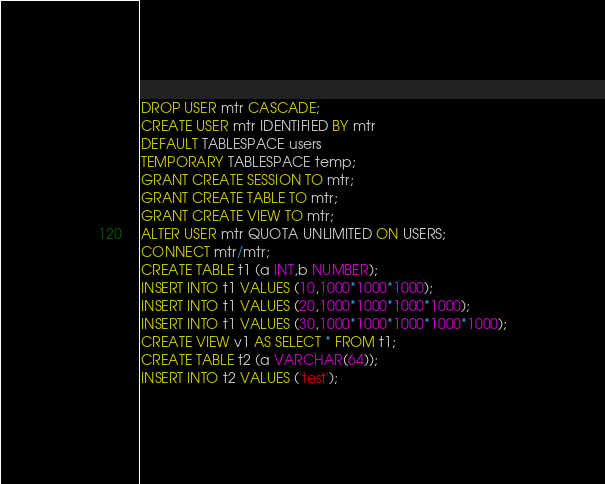<code> <loc_0><loc_0><loc_500><loc_500><_SQL_>DROP USER mtr CASCADE;
CREATE USER mtr IDENTIFIED BY mtr
DEFAULT TABLESPACE users
TEMPORARY TABLESPACE temp;
GRANT CREATE SESSION TO mtr;
GRANT CREATE TABLE TO mtr;
GRANT CREATE VIEW TO mtr;
ALTER USER mtr QUOTA UNLIMITED ON USERS;
CONNECT mtr/mtr;
CREATE TABLE t1 (a INT,b NUMBER);
INSERT INTO t1 VALUES (10,1000*1000*1000);
INSERT INTO t1 VALUES (20,1000*1000*1000*1000);
INSERT INTO t1 VALUES (30,1000*1000*1000*1000*1000);
CREATE VIEW v1 AS SELECT * FROM t1;
CREATE TABLE t2 (a VARCHAR(64));
INSERT INTO t2 VALUES ('test');
</code> 